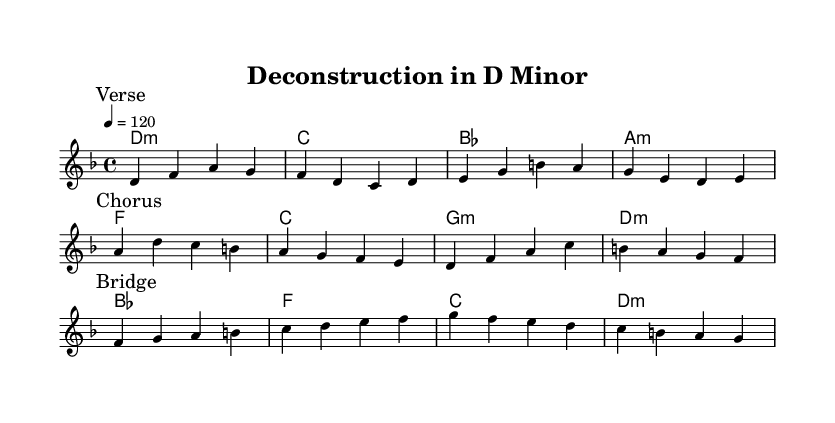What is the key signature of this music? The key signature is indicated by the "d" on the staff, which shows that there are two flats, affecting B and E, making it D minor.
Answer: D minor What is the time signature of this music? The time signature is shown as "4/4," indicating that there are four beats in each measure and a quarter note gets one beat.
Answer: 4/4 What is the tempo marking of this piece? The piece has a tempo marking of "4 = 120," meaning that there are 120 beats per minute with a quarter note counted as one beat.
Answer: 120 How many sections does this piece have? The music has three sections: a verse, a chorus, and a bridge, which are identified by the markings in the music.
Answer: Three What is the first lyric of the verse? The first lyric of the verse is "Frag," which is found at the beginning of the first line of lyrics.
Answer: Frag Which postmodern art concepts are referenced in the bridge lyrics? The bridge lyrics mention "appropriation," "pastiche," and "collage," which are key concepts in postmodern art, emphasizing the remixing of cultural elements.
Answer: Appropriation, pastiche, and collage What is the primary chord used in the chorus? The primary chord in the chorus is "d," as indicated in the chord changes, which starts the chorus's harmonic progression.
Answer: D 